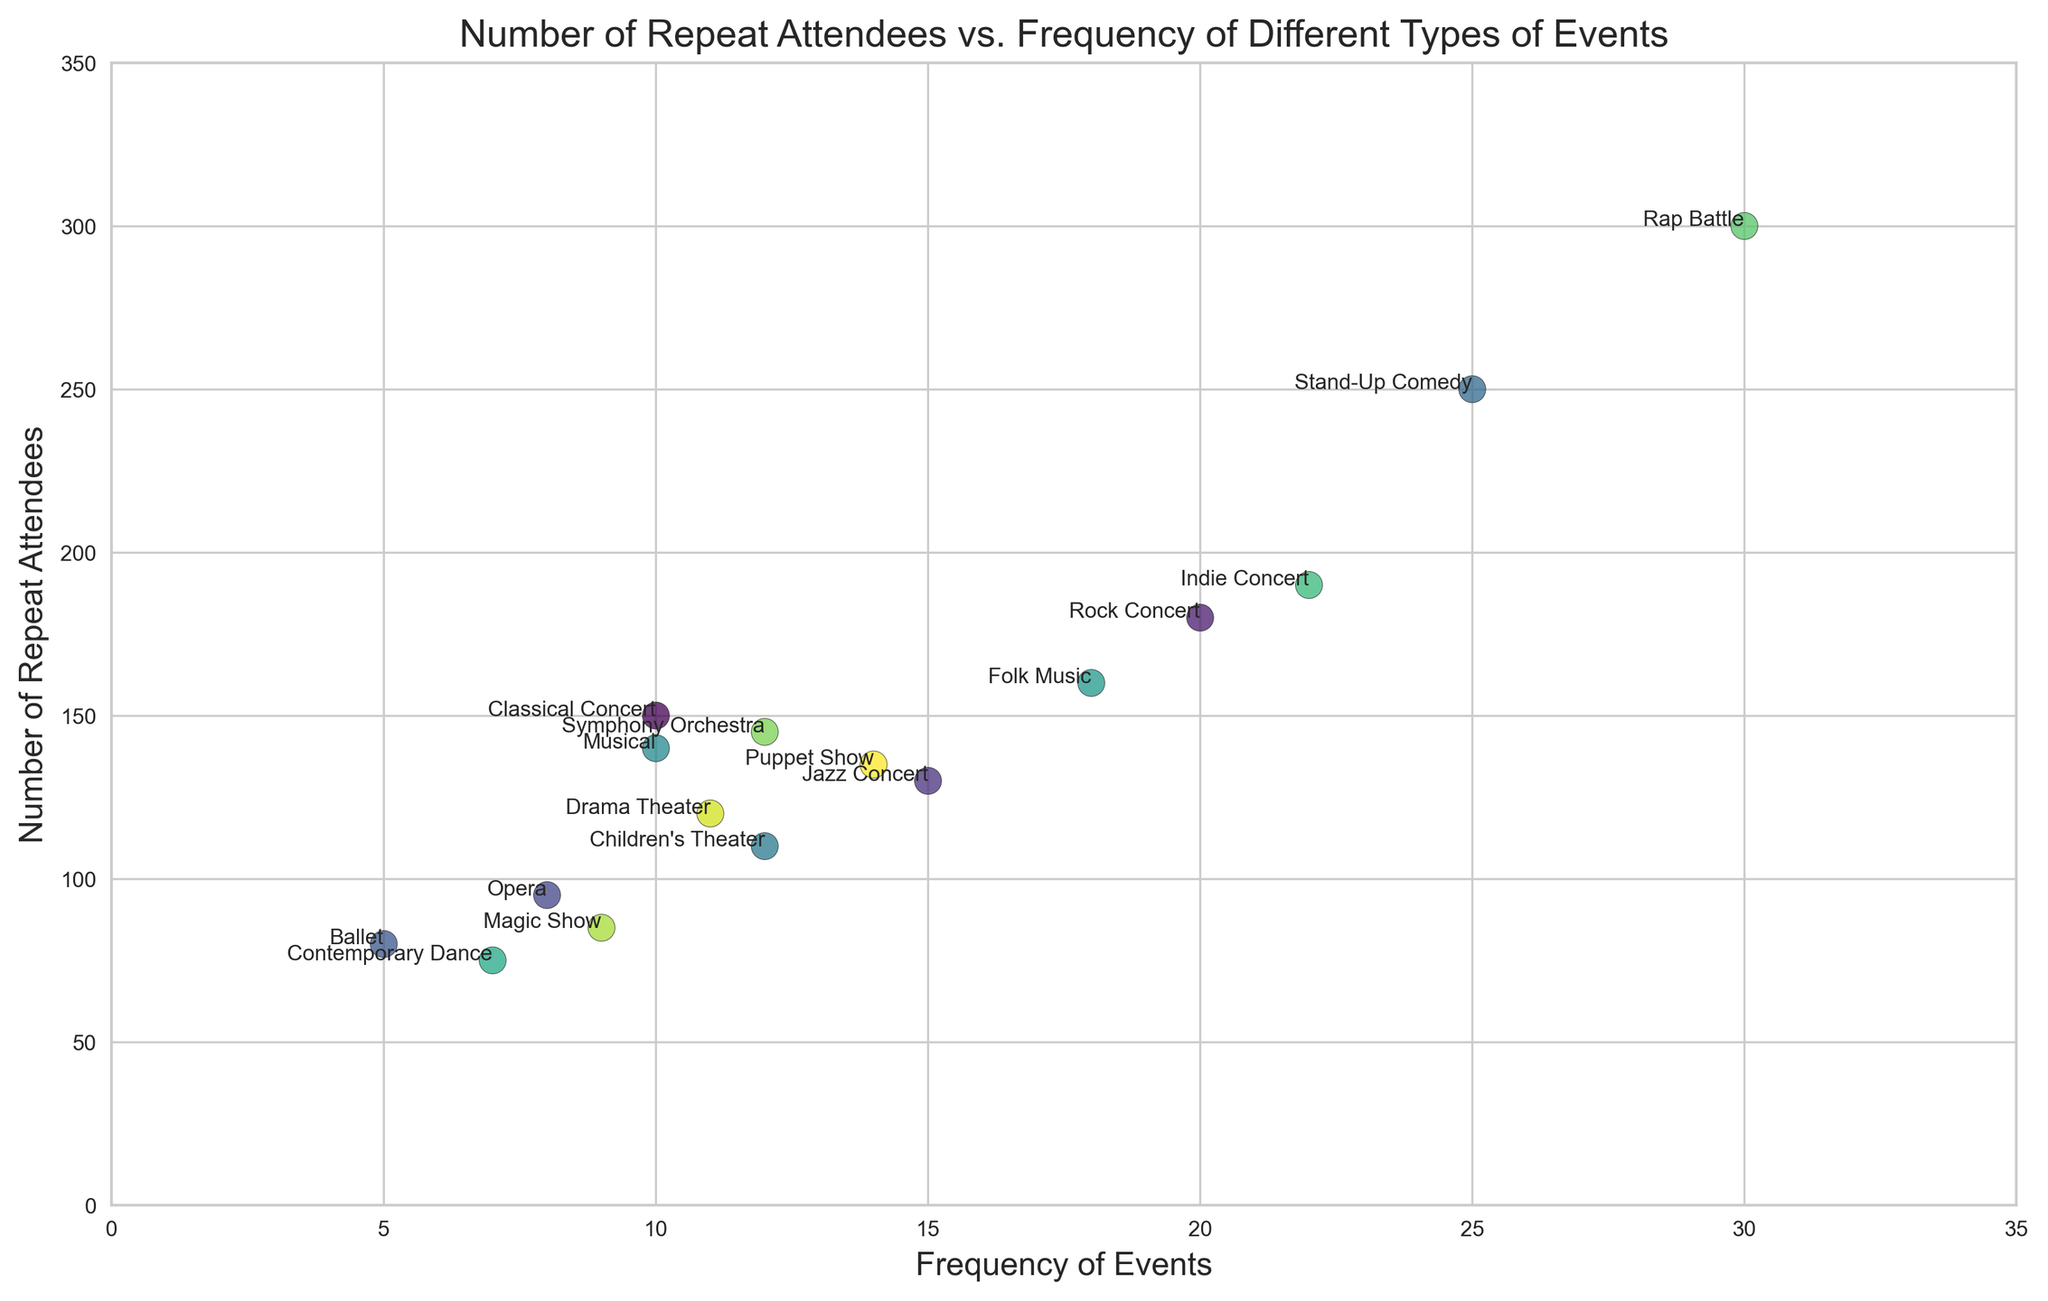Which event type has the highest number of repeat attendees? The scatter plot shows the number of repeat attendees on the y-axis. By looking at the topmost point, we can see that the "Rap Battle" event has the highest number of repeat attendees.
Answer: Rap Battle Which event occurs the most frequently? The x-axis of the scatter plot represents the frequency of events. By identifying the rightmost point on the x-axis, we can see that "Rap Battle" is the event with the highest frequency.
Answer: Rap Battle What is the average number of repeat attendees for events with a frequency of more than 20? First, identify the events that occur more than 20 times on the x-axis: Rock Concert (180 attendees), Indie Concert (190 attendees), and Rap Battle (300 attendees). Sum their attendees (180 + 190 + 300 = 670) and divide by the number of events (3).
Answer: 223.33 Which event type has the lowest frequency but more than 100 repeat attendees? Scan the x-axis for low-frequency values and then check the y-axis to see if the number of attendees is above 100. "Ballet" occurs 5 times but has 80 attendees, which is not greater than 100. "Opera" occurs 8 times and has 95 attendees, also not sufficient. "Children's Theater" occurs 12 times and has 110 attendees, which meets the criteria.
Answer: Children's Theater Are the number of repeat attendees for classical concerts greater than those for musicals? According to the scatter plot annotations for Classical Concert (150 attendees) and Musical (140 attendees), Classical Concert has more repeat attendees.
Answer: Yes What's the combined number of repeat attendees for Jazz Concert and Drama Theater? Jazz Concert has 130 repeat attendees, and Drama Theater has 120 repeat attendees. Sum these numbers to get the total (130 + 120).
Answer: 250 Which event stands out in terms of both high frequency and high number of repeat attendees? Examine points that are both to the right (high frequency) and high up (high number of attendees). "Rap Battle" stands out as having both a high frequency (30) and a high number of repeat attendees (300).
Answer: Rap Battle Compare the number of repeat attendees between Stand-Up Comedy and Indie Concert. Which one has more? Check their positions on the y-axis: Stand-Up Comedy has 250 repeat attendees and Indie Concert has 190 repeat attendees.
Answer: Stand-Up Comedy Among the events that occur 10 times, which one has the highest number of repeat attendees? Check the annotations at the x-value of 10. "Classical Concert" has 150 attendees, and "Musical" has 140 attendees, which means "Classical Concert" has the highest number of repeat attendees.
Answer: Classical Concert 